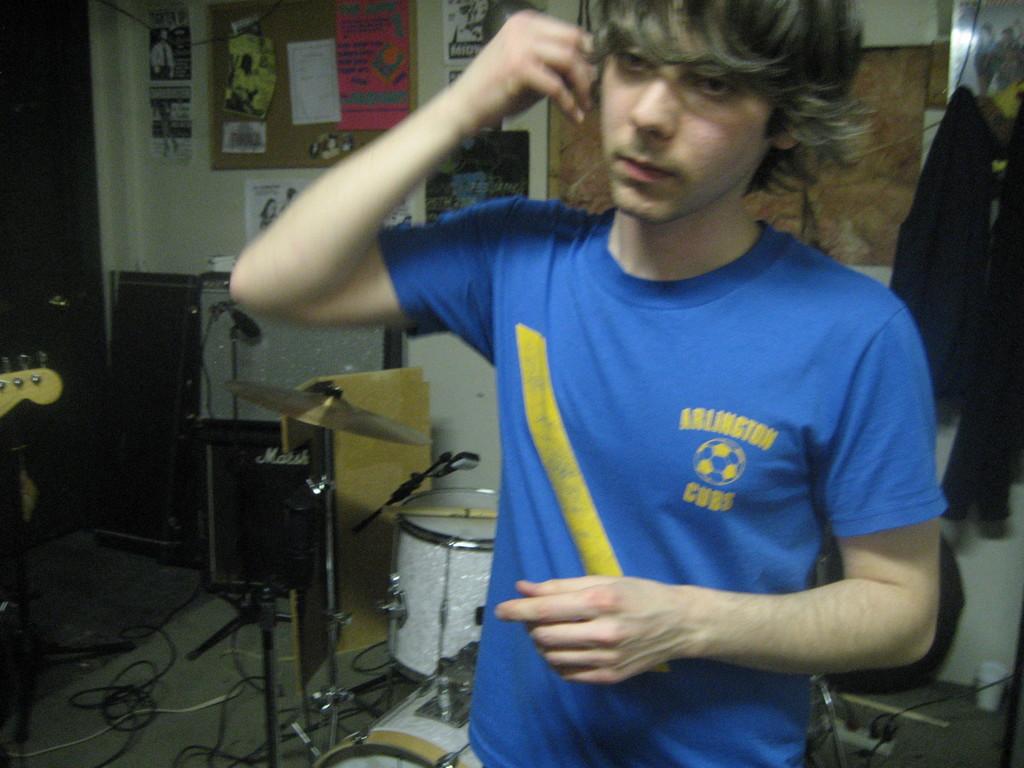Is he in a band?
Ensure brevity in your answer.  Yes. 